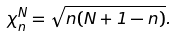<formula> <loc_0><loc_0><loc_500><loc_500>\chi _ { n } ^ { N } = \sqrt { n ( N + 1 - n ) } .</formula> 